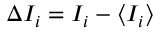<formula> <loc_0><loc_0><loc_500><loc_500>\Delta I _ { i } = I _ { i } - \langle I _ { i } \rangle</formula> 